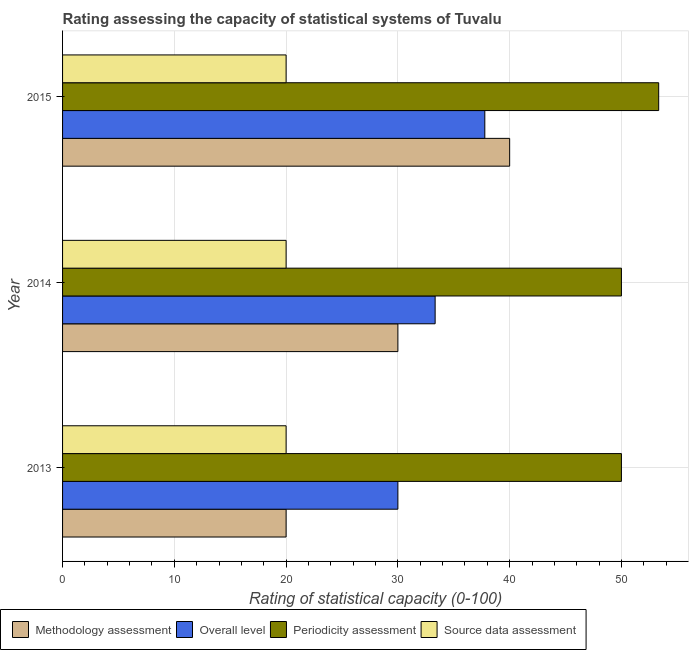How many different coloured bars are there?
Give a very brief answer. 4. Are the number of bars on each tick of the Y-axis equal?
Offer a terse response. Yes. How many bars are there on the 3rd tick from the bottom?
Your answer should be compact. 4. In how many cases, is the number of bars for a given year not equal to the number of legend labels?
Offer a very short reply. 0. Across all years, what is the maximum periodicity assessment rating?
Your response must be concise. 53.33. Across all years, what is the minimum source data assessment rating?
Give a very brief answer. 20. In which year was the methodology assessment rating maximum?
Offer a terse response. 2015. What is the total source data assessment rating in the graph?
Provide a short and direct response. 60. What is the difference between the periodicity assessment rating in 2014 and that in 2015?
Provide a succinct answer. -3.33. What is the difference between the source data assessment rating in 2015 and the overall level rating in 2013?
Provide a short and direct response. -10. What is the average overall level rating per year?
Offer a very short reply. 33.7. In the year 2014, what is the difference between the periodicity assessment rating and overall level rating?
Ensure brevity in your answer.  16.67. In how many years, is the periodicity assessment rating greater than 4 ?
Give a very brief answer. 3. What is the ratio of the periodicity assessment rating in 2013 to that in 2014?
Ensure brevity in your answer.  1. Is the overall level rating in 2014 less than that in 2015?
Your response must be concise. Yes. Is the difference between the methodology assessment rating in 2014 and 2015 greater than the difference between the periodicity assessment rating in 2014 and 2015?
Keep it short and to the point. No. What is the difference between the highest and the lowest periodicity assessment rating?
Offer a very short reply. 3.33. In how many years, is the periodicity assessment rating greater than the average periodicity assessment rating taken over all years?
Provide a succinct answer. 1. Is it the case that in every year, the sum of the methodology assessment rating and periodicity assessment rating is greater than the sum of source data assessment rating and overall level rating?
Make the answer very short. No. What does the 1st bar from the top in 2015 represents?
Give a very brief answer. Source data assessment. What does the 1st bar from the bottom in 2014 represents?
Keep it short and to the point. Methodology assessment. Is it the case that in every year, the sum of the methodology assessment rating and overall level rating is greater than the periodicity assessment rating?
Your answer should be very brief. No. How many bars are there?
Keep it short and to the point. 12. What is the difference between two consecutive major ticks on the X-axis?
Give a very brief answer. 10. Are the values on the major ticks of X-axis written in scientific E-notation?
Offer a very short reply. No. Does the graph contain any zero values?
Keep it short and to the point. No. How are the legend labels stacked?
Keep it short and to the point. Horizontal. What is the title of the graph?
Offer a terse response. Rating assessing the capacity of statistical systems of Tuvalu. What is the label or title of the X-axis?
Your response must be concise. Rating of statistical capacity (0-100). What is the Rating of statistical capacity (0-100) of Periodicity assessment in 2013?
Your answer should be very brief. 50. What is the Rating of statistical capacity (0-100) of Methodology assessment in 2014?
Offer a very short reply. 30. What is the Rating of statistical capacity (0-100) of Overall level in 2014?
Offer a terse response. 33.33. What is the Rating of statistical capacity (0-100) of Periodicity assessment in 2014?
Offer a terse response. 50. What is the Rating of statistical capacity (0-100) in Source data assessment in 2014?
Give a very brief answer. 20. What is the Rating of statistical capacity (0-100) in Methodology assessment in 2015?
Provide a short and direct response. 40. What is the Rating of statistical capacity (0-100) of Overall level in 2015?
Your response must be concise. 37.78. What is the Rating of statistical capacity (0-100) in Periodicity assessment in 2015?
Make the answer very short. 53.33. Across all years, what is the maximum Rating of statistical capacity (0-100) in Methodology assessment?
Ensure brevity in your answer.  40. Across all years, what is the maximum Rating of statistical capacity (0-100) of Overall level?
Keep it short and to the point. 37.78. Across all years, what is the maximum Rating of statistical capacity (0-100) in Periodicity assessment?
Keep it short and to the point. 53.33. What is the total Rating of statistical capacity (0-100) of Methodology assessment in the graph?
Your answer should be very brief. 90. What is the total Rating of statistical capacity (0-100) of Overall level in the graph?
Your response must be concise. 101.11. What is the total Rating of statistical capacity (0-100) in Periodicity assessment in the graph?
Offer a very short reply. 153.33. What is the difference between the Rating of statistical capacity (0-100) of Methodology assessment in 2013 and that in 2014?
Keep it short and to the point. -10. What is the difference between the Rating of statistical capacity (0-100) in Overall level in 2013 and that in 2014?
Your answer should be compact. -3.33. What is the difference between the Rating of statistical capacity (0-100) in Source data assessment in 2013 and that in 2014?
Your answer should be compact. 0. What is the difference between the Rating of statistical capacity (0-100) in Overall level in 2013 and that in 2015?
Ensure brevity in your answer.  -7.78. What is the difference between the Rating of statistical capacity (0-100) of Overall level in 2014 and that in 2015?
Your answer should be compact. -4.44. What is the difference between the Rating of statistical capacity (0-100) of Periodicity assessment in 2014 and that in 2015?
Keep it short and to the point. -3.33. What is the difference between the Rating of statistical capacity (0-100) in Methodology assessment in 2013 and the Rating of statistical capacity (0-100) in Overall level in 2014?
Your response must be concise. -13.33. What is the difference between the Rating of statistical capacity (0-100) of Methodology assessment in 2013 and the Rating of statistical capacity (0-100) of Source data assessment in 2014?
Give a very brief answer. 0. What is the difference between the Rating of statistical capacity (0-100) of Periodicity assessment in 2013 and the Rating of statistical capacity (0-100) of Source data assessment in 2014?
Offer a very short reply. 30. What is the difference between the Rating of statistical capacity (0-100) of Methodology assessment in 2013 and the Rating of statistical capacity (0-100) of Overall level in 2015?
Provide a succinct answer. -17.78. What is the difference between the Rating of statistical capacity (0-100) in Methodology assessment in 2013 and the Rating of statistical capacity (0-100) in Periodicity assessment in 2015?
Make the answer very short. -33.33. What is the difference between the Rating of statistical capacity (0-100) of Overall level in 2013 and the Rating of statistical capacity (0-100) of Periodicity assessment in 2015?
Give a very brief answer. -23.33. What is the difference between the Rating of statistical capacity (0-100) of Periodicity assessment in 2013 and the Rating of statistical capacity (0-100) of Source data assessment in 2015?
Provide a succinct answer. 30. What is the difference between the Rating of statistical capacity (0-100) in Methodology assessment in 2014 and the Rating of statistical capacity (0-100) in Overall level in 2015?
Keep it short and to the point. -7.78. What is the difference between the Rating of statistical capacity (0-100) of Methodology assessment in 2014 and the Rating of statistical capacity (0-100) of Periodicity assessment in 2015?
Provide a short and direct response. -23.33. What is the difference between the Rating of statistical capacity (0-100) of Methodology assessment in 2014 and the Rating of statistical capacity (0-100) of Source data assessment in 2015?
Make the answer very short. 10. What is the difference between the Rating of statistical capacity (0-100) in Overall level in 2014 and the Rating of statistical capacity (0-100) in Periodicity assessment in 2015?
Your response must be concise. -20. What is the difference between the Rating of statistical capacity (0-100) of Overall level in 2014 and the Rating of statistical capacity (0-100) of Source data assessment in 2015?
Ensure brevity in your answer.  13.33. What is the average Rating of statistical capacity (0-100) in Methodology assessment per year?
Ensure brevity in your answer.  30. What is the average Rating of statistical capacity (0-100) of Overall level per year?
Make the answer very short. 33.7. What is the average Rating of statistical capacity (0-100) in Periodicity assessment per year?
Provide a succinct answer. 51.11. What is the average Rating of statistical capacity (0-100) of Source data assessment per year?
Your answer should be compact. 20. In the year 2013, what is the difference between the Rating of statistical capacity (0-100) in Methodology assessment and Rating of statistical capacity (0-100) in Source data assessment?
Give a very brief answer. 0. In the year 2013, what is the difference between the Rating of statistical capacity (0-100) in Overall level and Rating of statistical capacity (0-100) in Source data assessment?
Provide a short and direct response. 10. In the year 2013, what is the difference between the Rating of statistical capacity (0-100) of Periodicity assessment and Rating of statistical capacity (0-100) of Source data assessment?
Offer a very short reply. 30. In the year 2014, what is the difference between the Rating of statistical capacity (0-100) of Methodology assessment and Rating of statistical capacity (0-100) of Overall level?
Offer a terse response. -3.33. In the year 2014, what is the difference between the Rating of statistical capacity (0-100) in Overall level and Rating of statistical capacity (0-100) in Periodicity assessment?
Ensure brevity in your answer.  -16.67. In the year 2014, what is the difference between the Rating of statistical capacity (0-100) in Overall level and Rating of statistical capacity (0-100) in Source data assessment?
Your response must be concise. 13.33. In the year 2014, what is the difference between the Rating of statistical capacity (0-100) in Periodicity assessment and Rating of statistical capacity (0-100) in Source data assessment?
Keep it short and to the point. 30. In the year 2015, what is the difference between the Rating of statistical capacity (0-100) in Methodology assessment and Rating of statistical capacity (0-100) in Overall level?
Your answer should be very brief. 2.22. In the year 2015, what is the difference between the Rating of statistical capacity (0-100) in Methodology assessment and Rating of statistical capacity (0-100) in Periodicity assessment?
Make the answer very short. -13.33. In the year 2015, what is the difference between the Rating of statistical capacity (0-100) of Methodology assessment and Rating of statistical capacity (0-100) of Source data assessment?
Offer a very short reply. 20. In the year 2015, what is the difference between the Rating of statistical capacity (0-100) in Overall level and Rating of statistical capacity (0-100) in Periodicity assessment?
Provide a short and direct response. -15.56. In the year 2015, what is the difference between the Rating of statistical capacity (0-100) in Overall level and Rating of statistical capacity (0-100) in Source data assessment?
Provide a short and direct response. 17.78. In the year 2015, what is the difference between the Rating of statistical capacity (0-100) of Periodicity assessment and Rating of statistical capacity (0-100) of Source data assessment?
Make the answer very short. 33.33. What is the ratio of the Rating of statistical capacity (0-100) of Methodology assessment in 2013 to that in 2014?
Give a very brief answer. 0.67. What is the ratio of the Rating of statistical capacity (0-100) in Periodicity assessment in 2013 to that in 2014?
Provide a short and direct response. 1. What is the ratio of the Rating of statistical capacity (0-100) in Source data assessment in 2013 to that in 2014?
Your response must be concise. 1. What is the ratio of the Rating of statistical capacity (0-100) in Methodology assessment in 2013 to that in 2015?
Ensure brevity in your answer.  0.5. What is the ratio of the Rating of statistical capacity (0-100) of Overall level in 2013 to that in 2015?
Your answer should be compact. 0.79. What is the ratio of the Rating of statistical capacity (0-100) in Source data assessment in 2013 to that in 2015?
Ensure brevity in your answer.  1. What is the ratio of the Rating of statistical capacity (0-100) in Overall level in 2014 to that in 2015?
Give a very brief answer. 0.88. What is the ratio of the Rating of statistical capacity (0-100) in Periodicity assessment in 2014 to that in 2015?
Keep it short and to the point. 0.94. What is the difference between the highest and the second highest Rating of statistical capacity (0-100) in Overall level?
Ensure brevity in your answer.  4.44. What is the difference between the highest and the lowest Rating of statistical capacity (0-100) of Methodology assessment?
Keep it short and to the point. 20. What is the difference between the highest and the lowest Rating of statistical capacity (0-100) in Overall level?
Ensure brevity in your answer.  7.78. What is the difference between the highest and the lowest Rating of statistical capacity (0-100) of Source data assessment?
Keep it short and to the point. 0. 